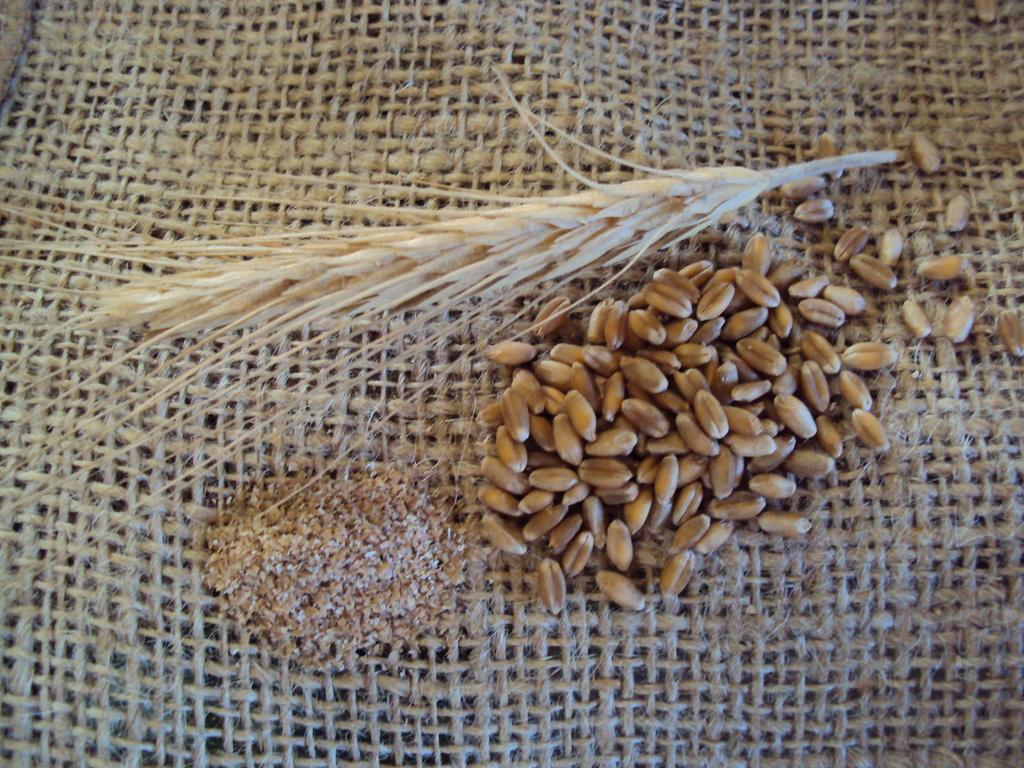What type of items can be seen in the image? There are food items in the image. What colors are the food items? The food items are in brown and cream colors. What is the color of the surface on which the food items are placed? The food items are on a brown color surface. What is the weight of the tub in the image? There is no tub present in the image, so it is not possible to determine its weight. 